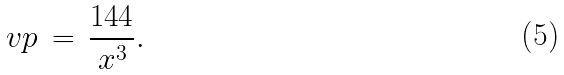<formula> <loc_0><loc_0><loc_500><loc_500>\ v p \, = \, \frac { 1 4 4 } { x ^ { 3 } } .</formula> 